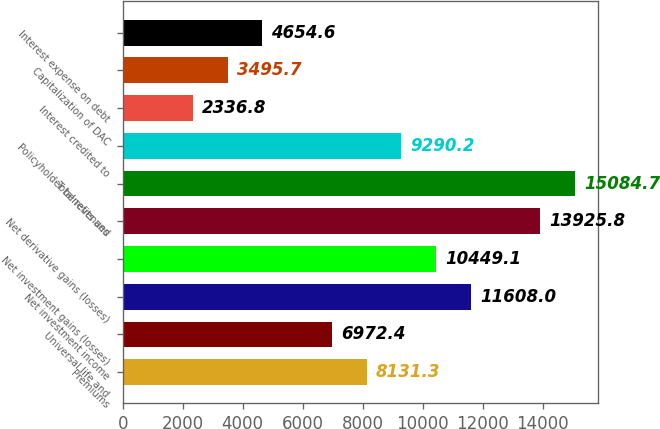Convert chart. <chart><loc_0><loc_0><loc_500><loc_500><bar_chart><fcel>Premiums<fcel>Universal life and<fcel>Net investment income<fcel>Net investment gains (losses)<fcel>Net derivative gains (losses)<fcel>Total revenues<fcel>Policyholder benefits and<fcel>Interest credited to<fcel>Capitalization of DAC<fcel>Interest expense on debt<nl><fcel>8131.3<fcel>6972.4<fcel>11608<fcel>10449.1<fcel>13925.8<fcel>15084.7<fcel>9290.2<fcel>2336.8<fcel>3495.7<fcel>4654.6<nl></chart> 